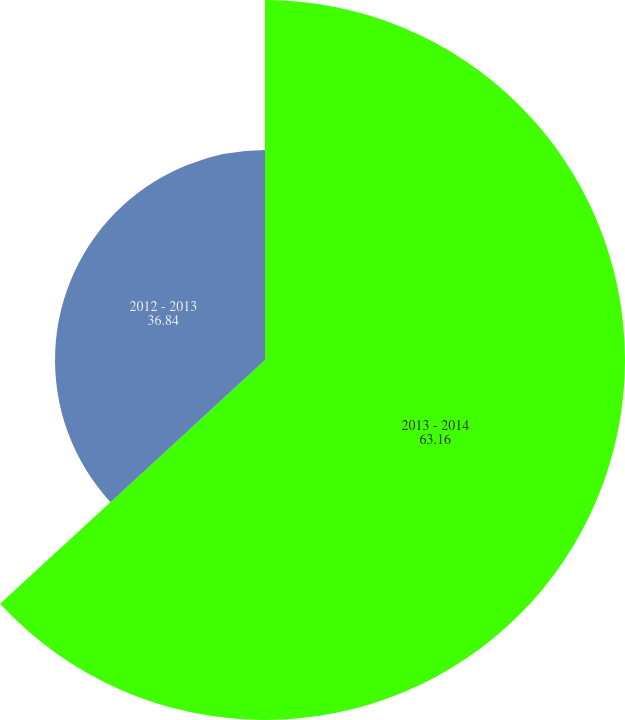Convert chart. <chart><loc_0><loc_0><loc_500><loc_500><pie_chart><fcel>2013 - 2014<fcel>2012 - 2013<nl><fcel>63.16%<fcel>36.84%<nl></chart> 